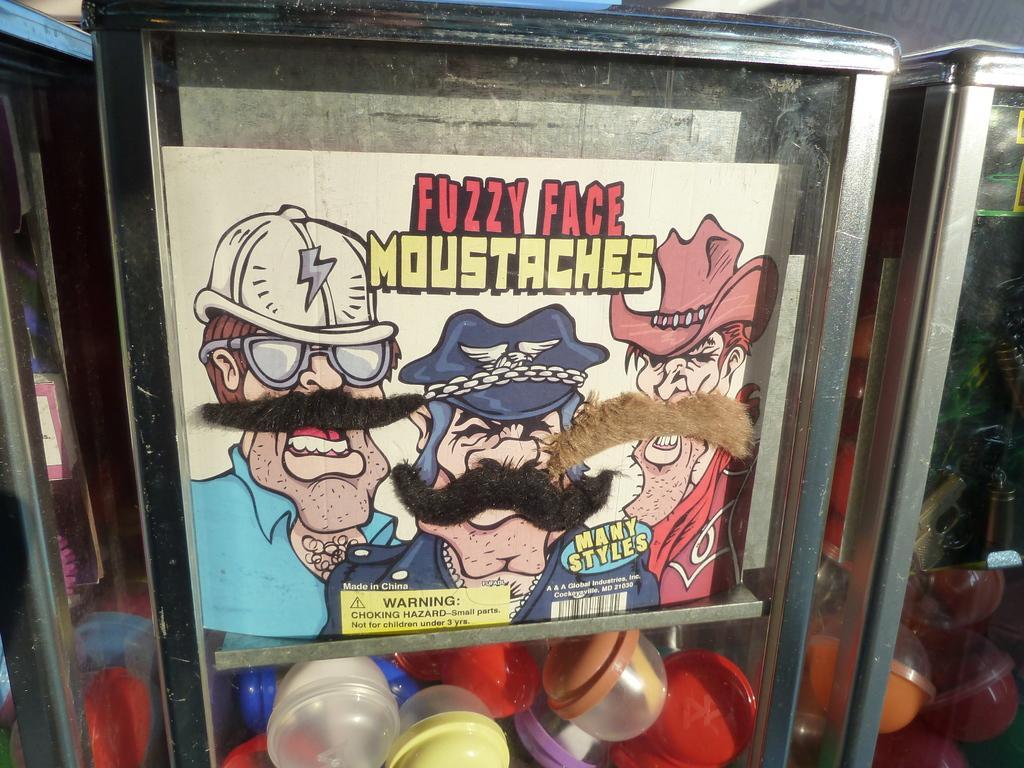In one or two sentences, can you explain what this image depicts? In this image there are containers and we can see bowls placed in the containers and there is a board. 